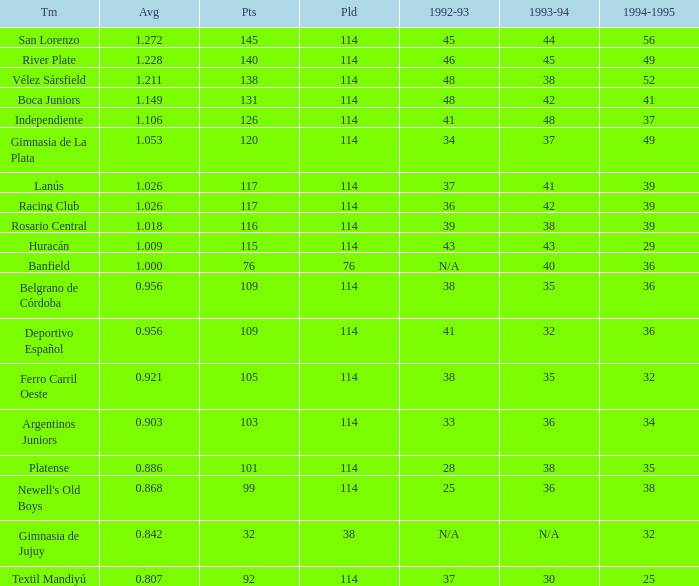Would you mind parsing the complete table? {'header': ['Tm', 'Avg', 'Pts', 'Pld', '1992-93', '1993-94', '1994-1995'], 'rows': [['San Lorenzo', '1.272', '145', '114', '45', '44', '56'], ['River Plate', '1.228', '140', '114', '46', '45', '49'], ['Vélez Sársfield', '1.211', '138', '114', '48', '38', '52'], ['Boca Juniors', '1.149', '131', '114', '48', '42', '41'], ['Independiente', '1.106', '126', '114', '41', '48', '37'], ['Gimnasia de La Plata', '1.053', '120', '114', '34', '37', '49'], ['Lanús', '1.026', '117', '114', '37', '41', '39'], ['Racing Club', '1.026', '117', '114', '36', '42', '39'], ['Rosario Central', '1.018', '116', '114', '39', '38', '39'], ['Huracán', '1.009', '115', '114', '43', '43', '29'], ['Banfield', '1.000', '76', '76', 'N/A', '40', '36'], ['Belgrano de Córdoba', '0.956', '109', '114', '38', '35', '36'], ['Deportivo Español', '0.956', '109', '114', '41', '32', '36'], ['Ferro Carril Oeste', '0.921', '105', '114', '38', '35', '32'], ['Argentinos Juniors', '0.903', '103', '114', '33', '36', '34'], ['Platense', '0.886', '101', '114', '28', '38', '35'], ["Newell's Old Boys", '0.868', '99', '114', '25', '36', '38'], ['Gimnasia de Jujuy', '0.842', '32', '38', 'N/A', 'N/A', '32'], ['Textil Mandiyú', '0.807', '92', '114', '37', '30', '25']]} Name the team for 1993-94 for 32 Deportivo Español. 